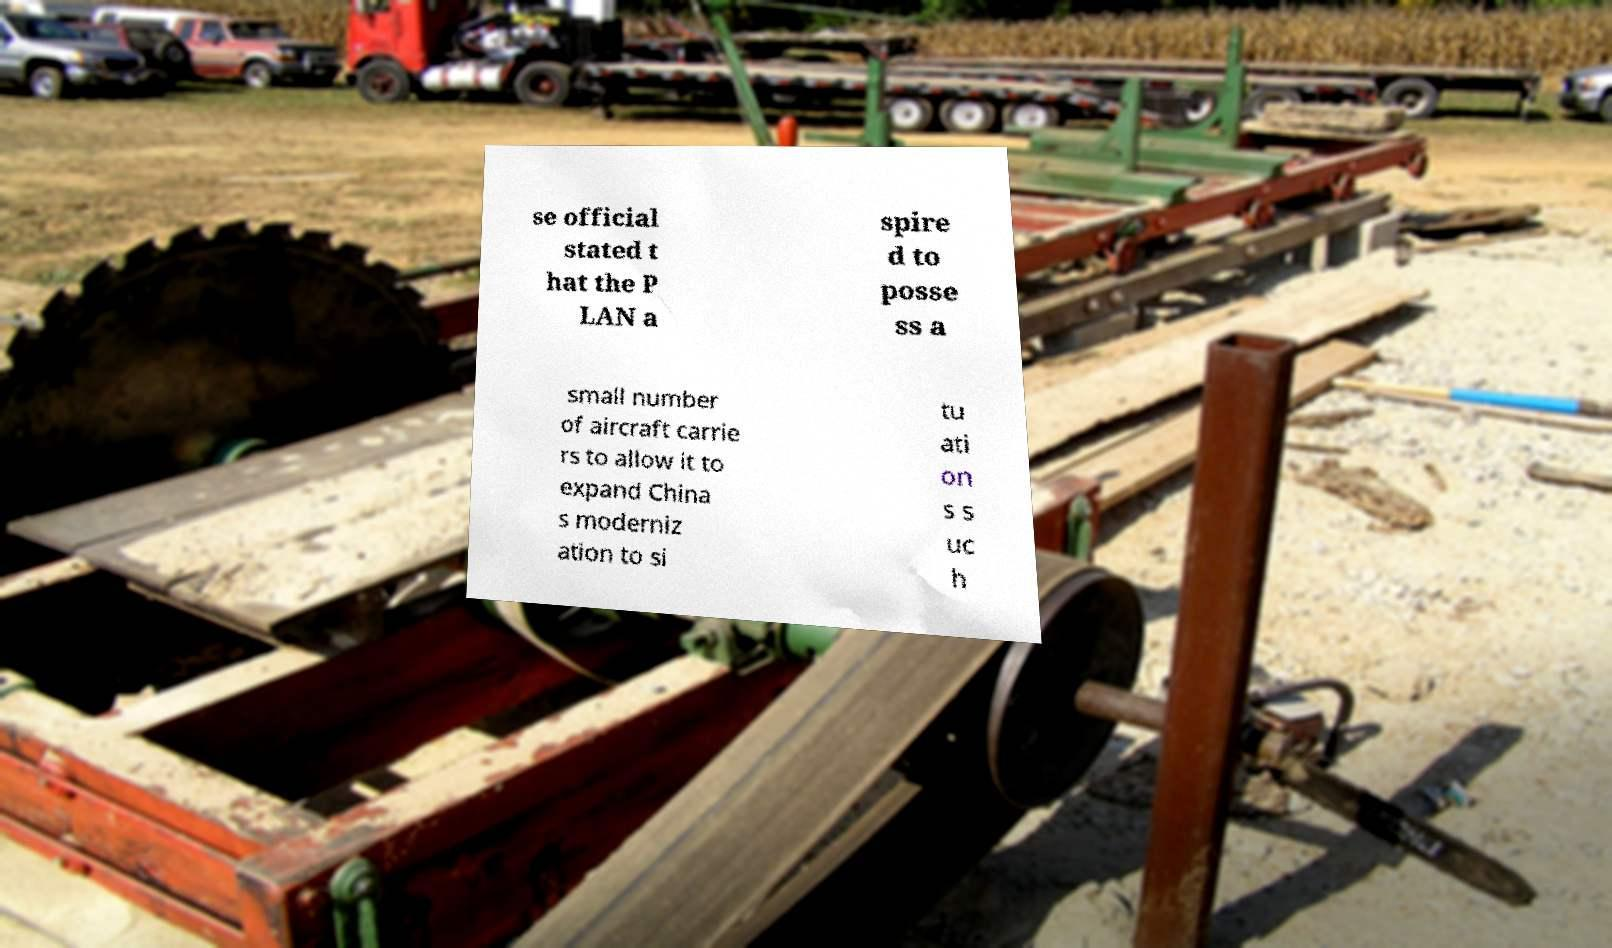Could you assist in decoding the text presented in this image and type it out clearly? se official stated t hat the P LAN a spire d to posse ss a small number of aircraft carrie rs to allow it to expand China s moderniz ation to si tu ati on s s uc h 